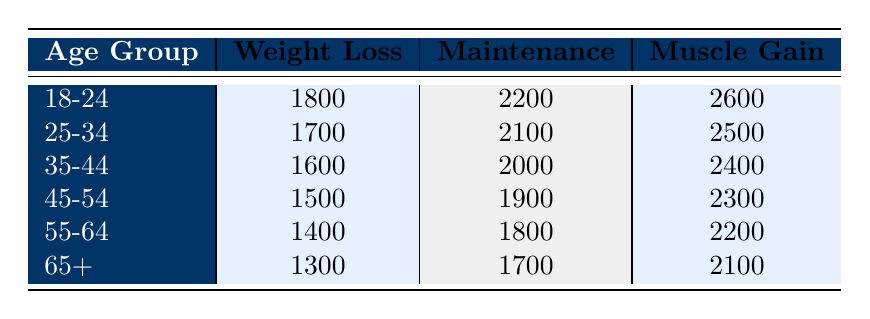What is the recommended caloric intake for muscle gain for clients aged 35-44? The table shows that for the age group 35-44, the recommended caloric intake for muscle gain is 2400.
Answer: 2400 What is the caloric intake difference between weight loss and maintenance for clients aged 25-34? For clients aged 25-34, the weight loss intake is 1700 and the maintenance intake is 2100. The difference is 2100 - 1700 = 400.
Answer: 400 Is the recommended caloric intake for maintenance greater than that for muscle gain in the 45-54 age group? The table indicates that for the 45-54 age group, the maintenance intake is 1900 while the muscle gain intake is 2300. Since 1900 is less than 2300, the answer is no.
Answer: No What is the average recommended caloric intake for weight loss across all age groups? To find the average weight loss intake, sum the values for all age groups: 1800 + 1700 + 1600 + 1500 + 1400 + 1300 = 10300. There are 6 age groups, so the average is 10300 / 6 = 1716.67.
Answer: 1716.67 Which age group has the highest recommended caloric intake for weight loss? By inspecting the table, the 18-24 age group has the highest caloric intake for weight loss at 1800.
Answer: 18-24 What is the recommended caloric intake for muscle gain for those aged 55-64 compared to those aged 65+? The table shows that for the age group 55-64, the intake is 2200, and for 65+, it is 2100. Therefore, 2200 is greater than 2100. The answer is yes.
Answer: Yes What is the total recommended caloric intake for weight loss and muscle gain for the 25-34 age group? For the 25-34 age group, weight loss intake is 1700 and muscle gain intake is 2500. The total is 1700 + 2500 = 4200.
Answer: 4200 Is the caloric intake for maintenance in the 55-64 age group less than the intake for weight loss in the 45-54 age group? For the 55-64 age group, the maintenance intake is 1800, while for the 45-54 group, the weight loss intake is 1500. Since 1800 is greater than 1500, the answer is no.
Answer: No 